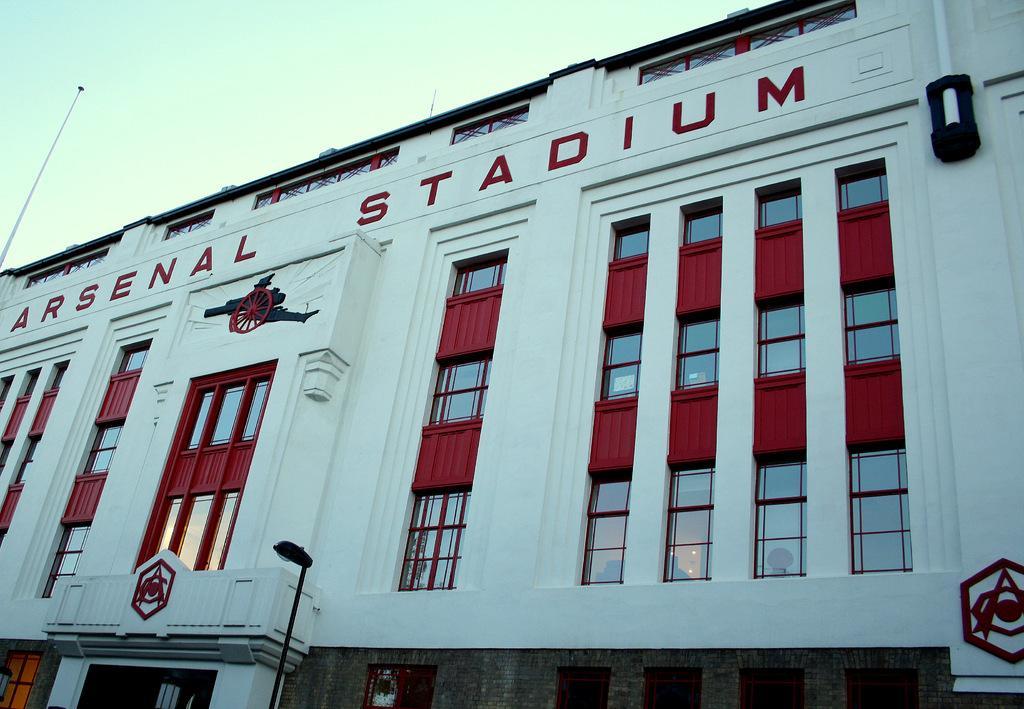In one or two sentences, can you explain what this image depicts? In this picture we can see poles, building with windows and in the background we can see the sky. 